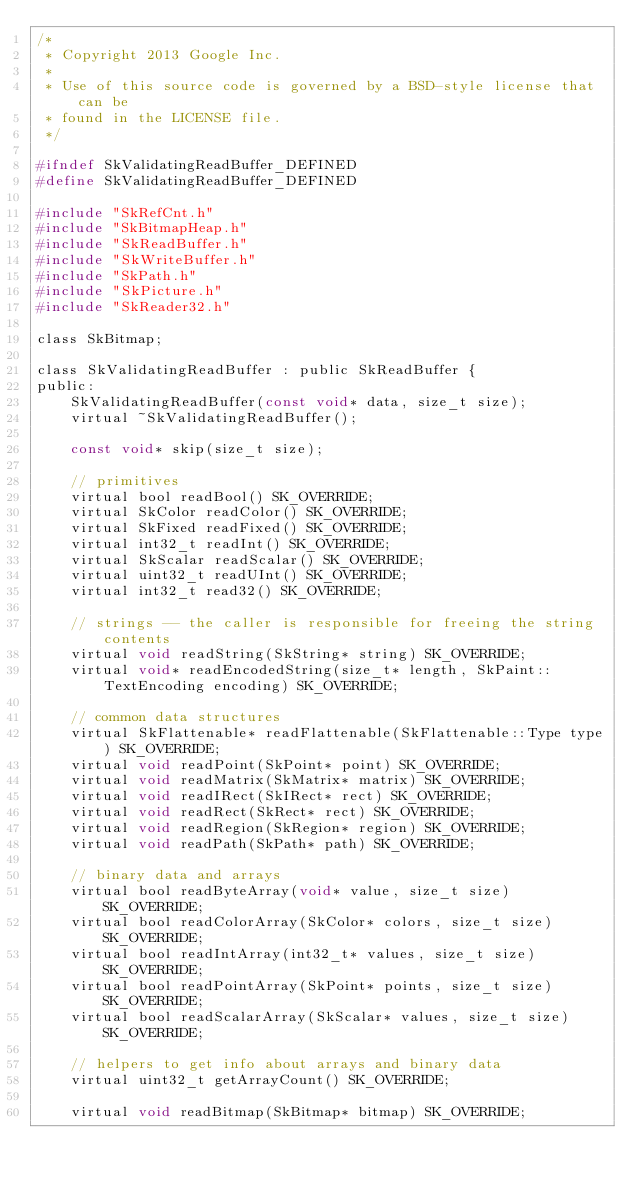<code> <loc_0><loc_0><loc_500><loc_500><_C_>/*
 * Copyright 2013 Google Inc.
 *
 * Use of this source code is governed by a BSD-style license that can be
 * found in the LICENSE file.
 */

#ifndef SkValidatingReadBuffer_DEFINED
#define SkValidatingReadBuffer_DEFINED

#include "SkRefCnt.h"
#include "SkBitmapHeap.h"
#include "SkReadBuffer.h"
#include "SkWriteBuffer.h"
#include "SkPath.h"
#include "SkPicture.h"
#include "SkReader32.h"

class SkBitmap;

class SkValidatingReadBuffer : public SkReadBuffer {
public:
    SkValidatingReadBuffer(const void* data, size_t size);
    virtual ~SkValidatingReadBuffer();

    const void* skip(size_t size);

    // primitives
    virtual bool readBool() SK_OVERRIDE;
    virtual SkColor readColor() SK_OVERRIDE;
    virtual SkFixed readFixed() SK_OVERRIDE;
    virtual int32_t readInt() SK_OVERRIDE;
    virtual SkScalar readScalar() SK_OVERRIDE;
    virtual uint32_t readUInt() SK_OVERRIDE;
    virtual int32_t read32() SK_OVERRIDE;

    // strings -- the caller is responsible for freeing the string contents
    virtual void readString(SkString* string) SK_OVERRIDE;
    virtual void* readEncodedString(size_t* length, SkPaint::TextEncoding encoding) SK_OVERRIDE;

    // common data structures
    virtual SkFlattenable* readFlattenable(SkFlattenable::Type type) SK_OVERRIDE;
    virtual void readPoint(SkPoint* point) SK_OVERRIDE;
    virtual void readMatrix(SkMatrix* matrix) SK_OVERRIDE;
    virtual void readIRect(SkIRect* rect) SK_OVERRIDE;
    virtual void readRect(SkRect* rect) SK_OVERRIDE;
    virtual void readRegion(SkRegion* region) SK_OVERRIDE;
    virtual void readPath(SkPath* path) SK_OVERRIDE;

    // binary data and arrays
    virtual bool readByteArray(void* value, size_t size) SK_OVERRIDE;
    virtual bool readColorArray(SkColor* colors, size_t size) SK_OVERRIDE;
    virtual bool readIntArray(int32_t* values, size_t size) SK_OVERRIDE;
    virtual bool readPointArray(SkPoint* points, size_t size) SK_OVERRIDE;
    virtual bool readScalarArray(SkScalar* values, size_t size) SK_OVERRIDE;

    // helpers to get info about arrays and binary data
    virtual uint32_t getArrayCount() SK_OVERRIDE;

    virtual void readBitmap(SkBitmap* bitmap) SK_OVERRIDE;</code> 